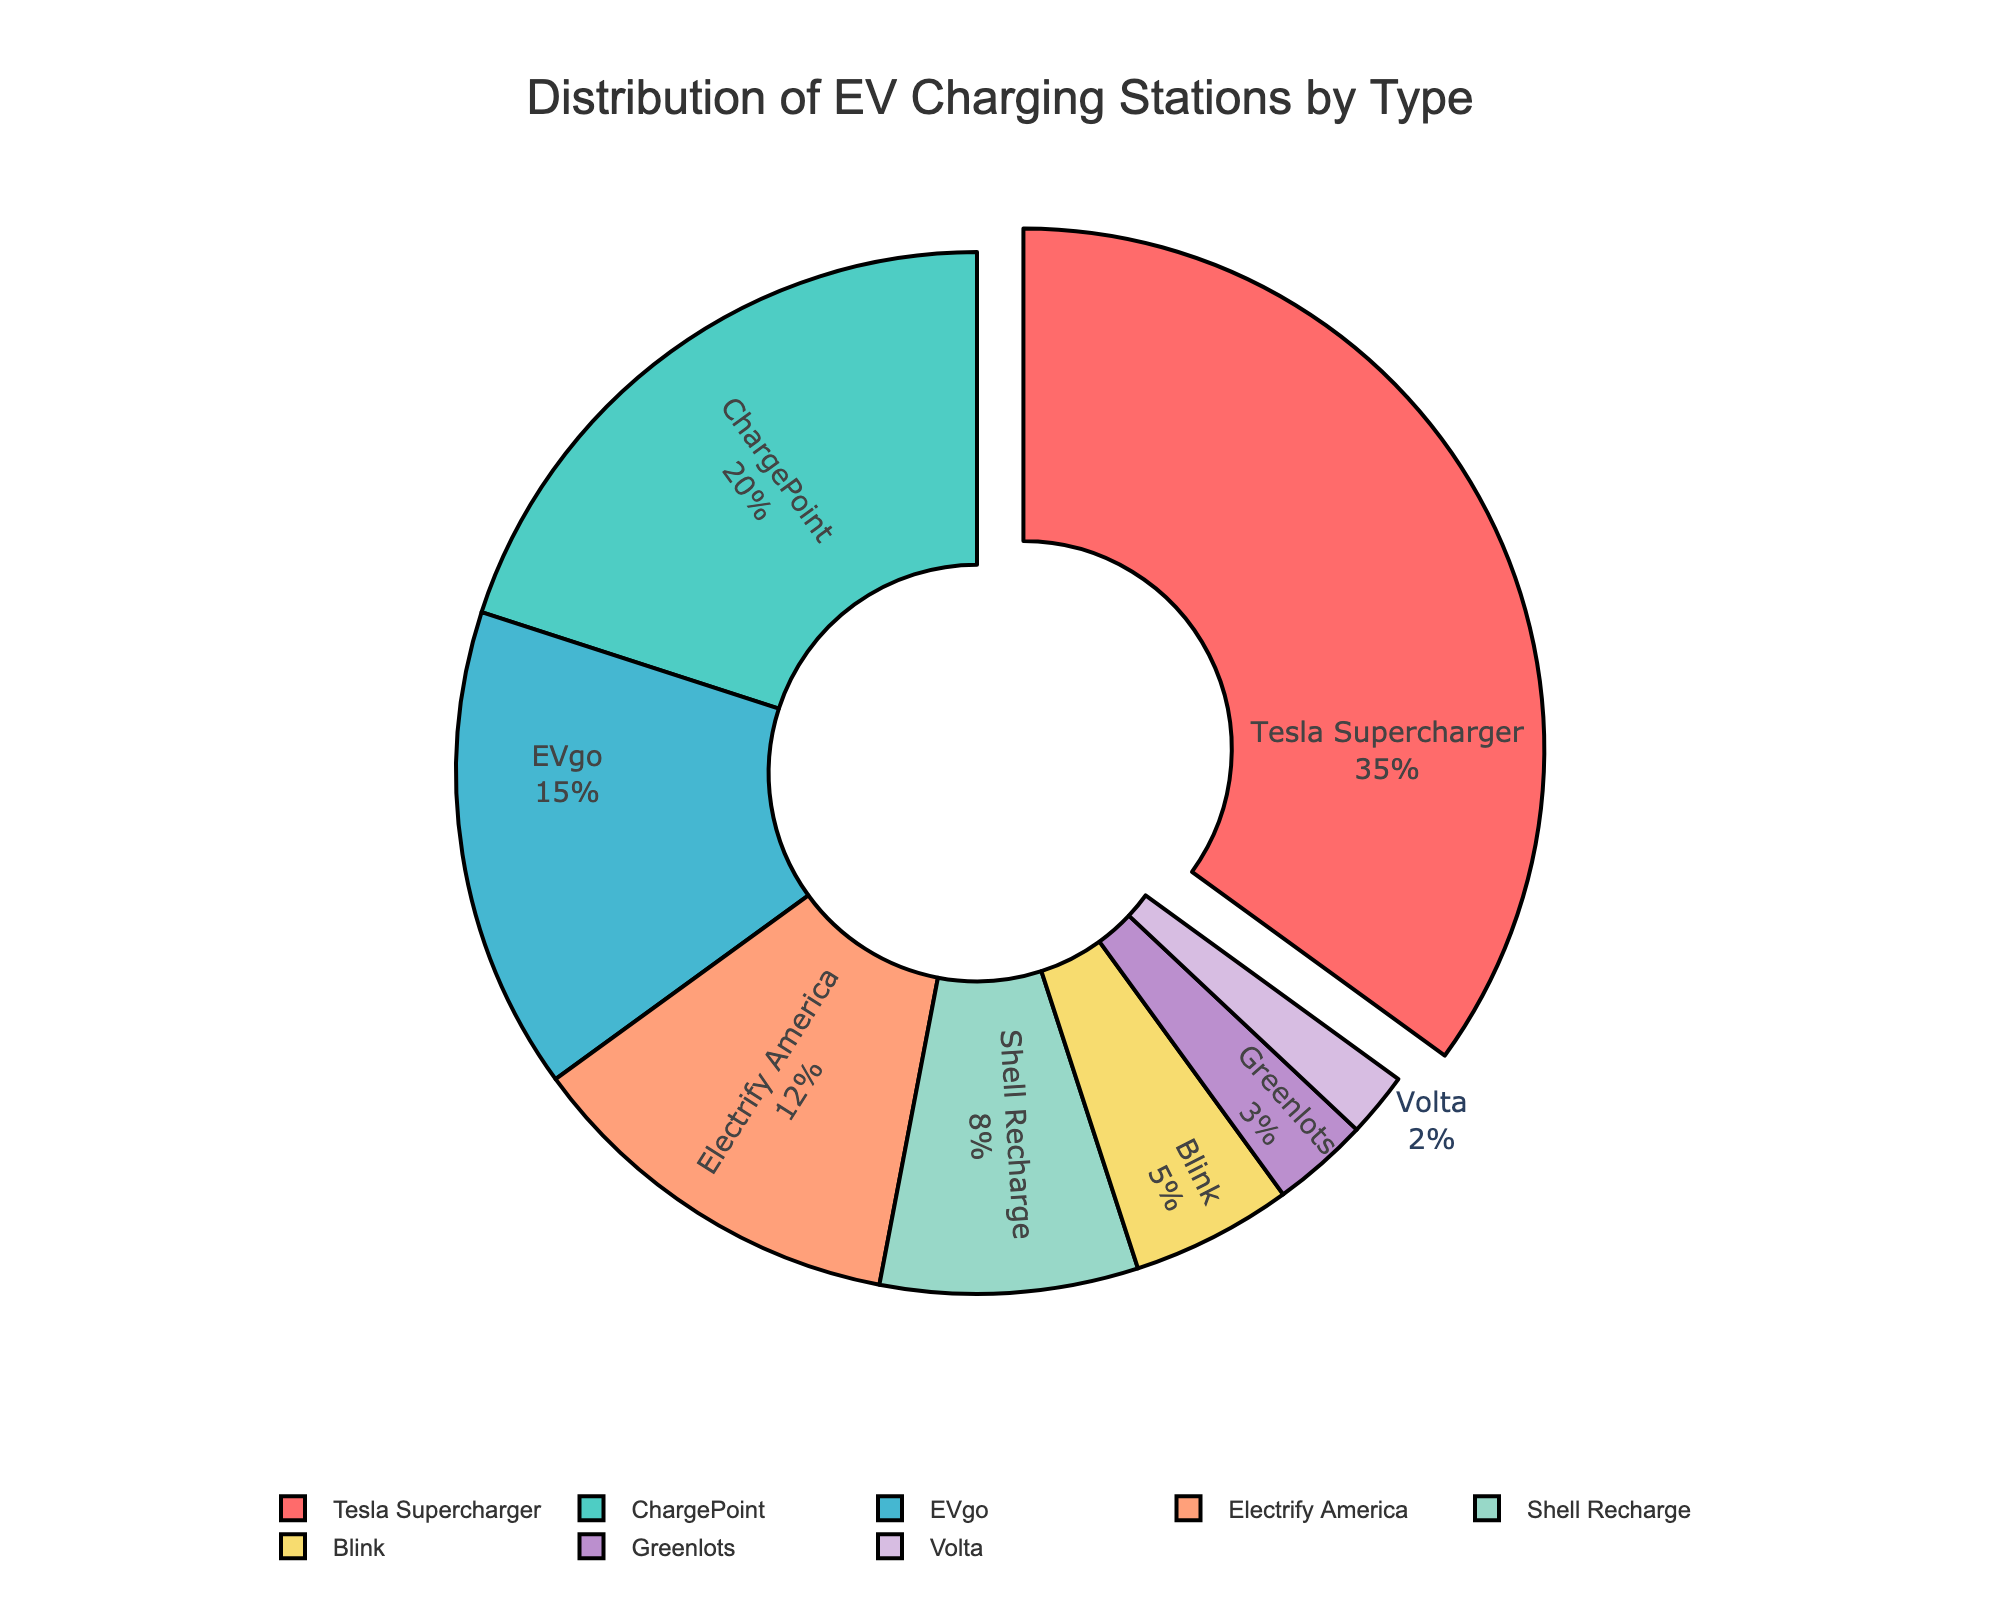Which type of EV charging station has the highest distribution? The Tesla Supercharger slice is the largest at 35%.
Answer: Tesla Supercharger Which two types of EV charging stations together constitute more than half of the distribution? Tesla Supercharger (35%) and ChargePoint (20%) together make up 55%.
Answer: Tesla Supercharger and ChargePoint What is the difference in the percentage distribution between EVgo and Shell Recharge? EVgo is at 15% and Shell Recharge is at 8%. The difference is 15% - 8% = 7%.
Answer: 7% Which four types of EV charging stations together make up less than 20% of the distribution? Greenlots (3%), Volta (2%), Blink (5%), and Shell Recharge (8%) add up to 3% + 2% + 5% + 8% = 18%.
Answer: Greenlots, Volta, Blink, and Shell Recharge How much larger is the distribution of Tesla Supercharger compared to Electrify America? Tesla Supercharger is 35% and Electrify America is at 12%. The difference is 35% - 12% = 23%.
Answer: 23% What is the total distribution percentage of ChargePoint, Blink, and Volta combined? ChargePoint is at 20%, Blink is at 5%, and Volta is at 2%. The total is 20% + 5% + 2% = 27%.
Answer: 27% Considering the visual size of the slices, which type of EV charging station is represented by a yellow color? The yellow slice corresponds to Electrify America, which has a 12% distribution.
Answer: Electrify America Which type of EV charging station uses a darker color compared to Volta, and what is its percentage? EVgo uses a darker color compared to Volta, and it has a 15% distribution.
Answer: EVgo; 15% If the percentage of Tesla Supercharger and ChargePoint together is reduced by 10%, what would their combined percentage be? Currently, Tesla Supercharger is 35% and ChargePoint is 20%, totaling 55%. Reducing by 10% gives 55% - 10% = 45%.
Answer: 45% What is the combined percentage of the least three common types of EV charging stations? Greenlots (3%), Volta (2%), and Blink (5%) add up to 3% + 2% + 5% = 10%.
Answer: 10% 